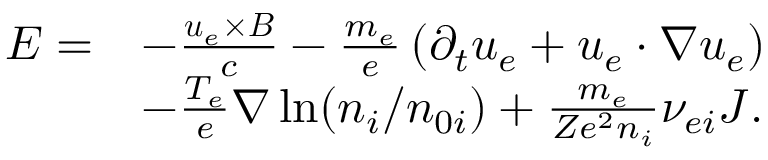<formula> <loc_0><loc_0><loc_500><loc_500>\begin{array} { r l } { E = } & { - \frac { u _ { e } \times B } { c } - \frac { m _ { e } } { e } \left ( \partial _ { t } u _ { e } + u _ { e } \cdot \nabla u _ { e } \right ) } \\ & { - \frac { T _ { e } } { e } \nabla \ln ( n _ { i } / n _ { 0 i } ) + \frac { m _ { e } } { Z e ^ { 2 } n _ { i } } \nu _ { e i } J . } \end{array}</formula> 